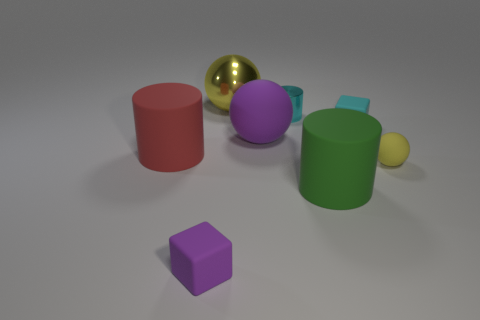There is a big red cylinder; are there any small metal cylinders behind it?
Provide a succinct answer. Yes. What number of other objects are the same shape as the small cyan matte object?
Make the answer very short. 1. What is the color of the other sphere that is the same size as the purple ball?
Keep it short and to the point. Yellow. Is the number of small cyan blocks on the left side of the yellow shiny thing less than the number of large rubber things behind the tiny yellow rubber sphere?
Provide a short and direct response. Yes. There is a block that is right of the yellow sphere that is behind the tiny yellow rubber sphere; how many tiny yellow objects are behind it?
Offer a terse response. 0. What size is the green rubber object that is the same shape as the big red matte object?
Provide a short and direct response. Large. Are there fewer purple rubber cubes that are left of the big red cylinder than tiny balls?
Make the answer very short. Yes. Does the big yellow thing have the same shape as the tiny yellow thing?
Keep it short and to the point. Yes. There is another matte object that is the same shape as the tiny purple thing; what color is it?
Offer a terse response. Cyan. What number of large metal objects have the same color as the tiny sphere?
Provide a short and direct response. 1. 